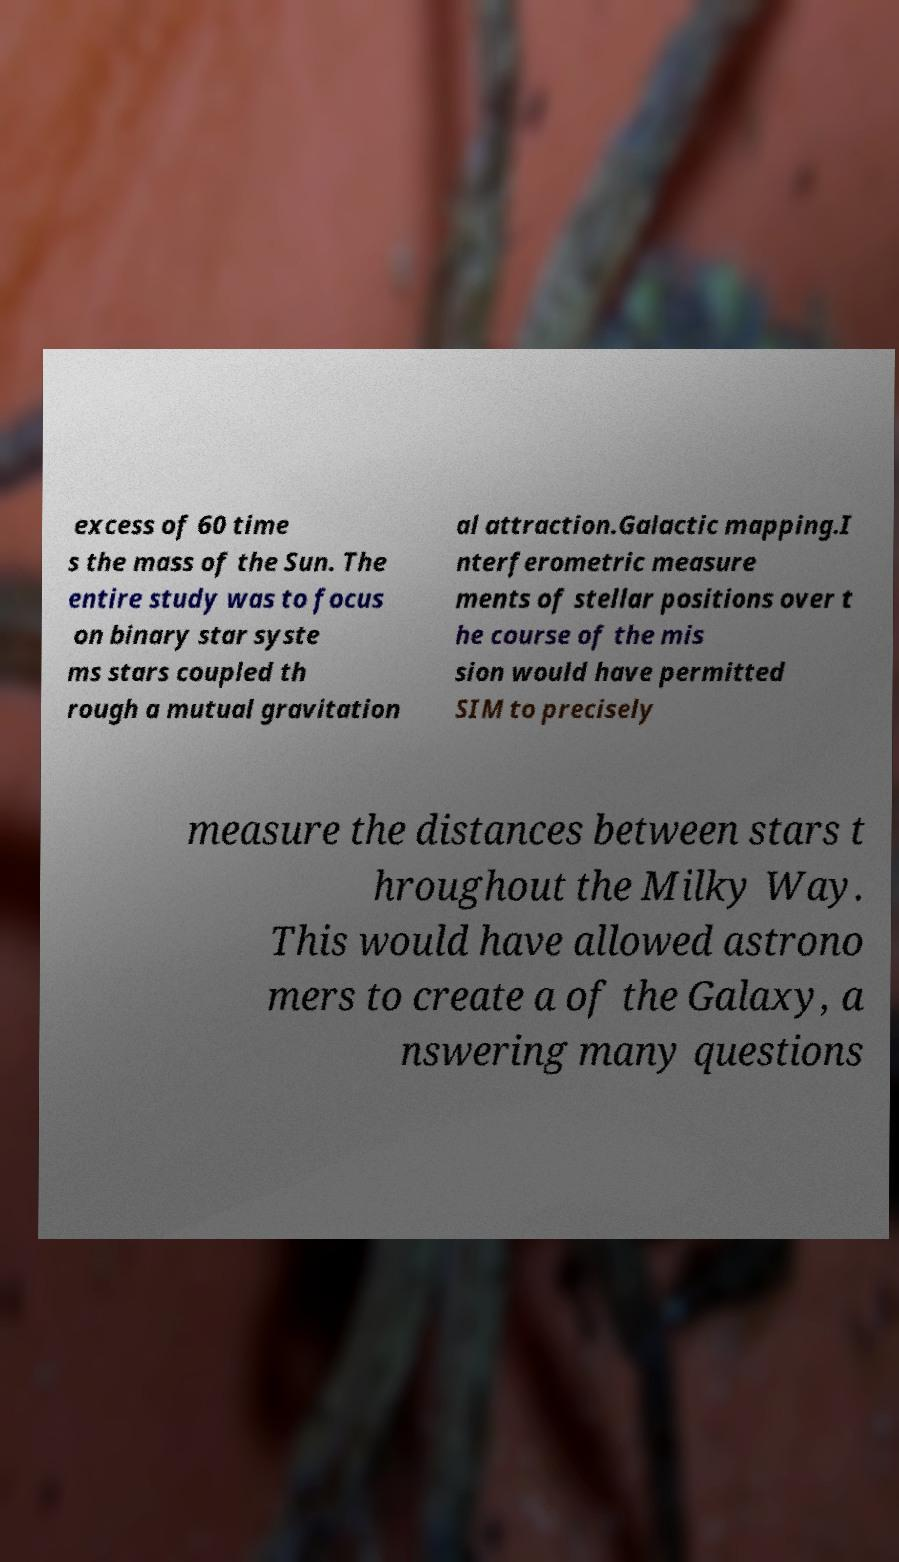I need the written content from this picture converted into text. Can you do that? excess of 60 time s the mass of the Sun. The entire study was to focus on binary star syste ms stars coupled th rough a mutual gravitation al attraction.Galactic mapping.I nterferometric measure ments of stellar positions over t he course of the mis sion would have permitted SIM to precisely measure the distances between stars t hroughout the Milky Way. This would have allowed astrono mers to create a of the Galaxy, a nswering many questions 